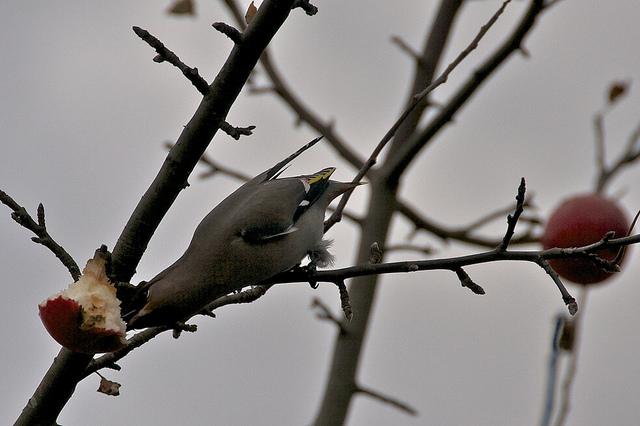What is this bird eating?
Be succinct. Apple. What kind of fowl is it?
Be succinct. Pigeon. What type of fruit does the bird have?
Quick response, please. Apple. What color are the plants?
Short answer required. Red. Why is one piece of fruit not whole?
Be succinct. Eaten. How many birds are pictured?
Answer briefly. 1. 